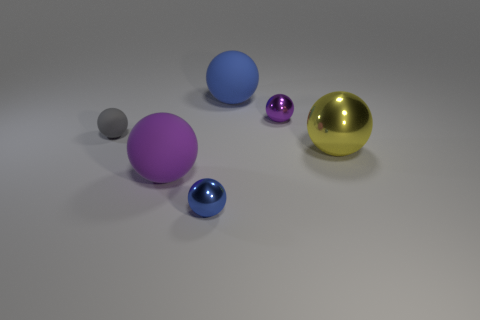What is the material of the small purple object that is the same shape as the large metal thing?
Ensure brevity in your answer.  Metal. Are there more big yellow metal objects than rubber objects?
Keep it short and to the point. No. There is a tiny rubber object; is it the same color as the large thing that is in front of the large metal object?
Provide a succinct answer. No. There is a metallic thing that is both behind the large purple rubber sphere and on the left side of the yellow shiny thing; what color is it?
Your answer should be compact. Purple. What number of other things are the same material as the tiny purple object?
Offer a terse response. 2. Are there fewer large rubber balls than big things?
Your answer should be compact. Yes. Does the small purple ball have the same material as the big ball left of the blue metallic thing?
Provide a succinct answer. No. There is a tiny metallic object that is in front of the small gray matte sphere; what is its shape?
Offer a very short reply. Sphere. Is there anything else that is the same color as the large shiny object?
Keep it short and to the point. No. Are there fewer large purple spheres that are behind the gray ball than tiny green blocks?
Ensure brevity in your answer.  No. 